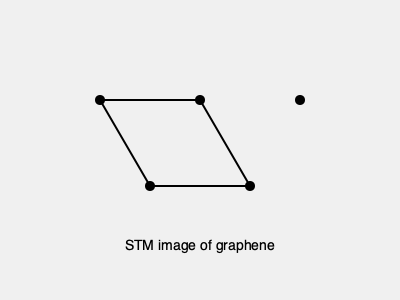Based on the STM image of graphene shown above, calculate the lattice constant of graphene. Assume the distance between the two adjacent bright spots in the horizontal direction is 0.246 nm. To calculate the lattice constant of graphene from the given STM image, we need to follow these steps:

1. Identify the unit cell: The hexagonal structure in the image represents the graphene lattice. The bright spots are the carbon atoms.

2. Recognize the given information: The distance between two adjacent bright spots in the horizontal direction is 0.246 nm. This corresponds to the distance between next-nearest neighbor carbon atoms in graphene.

3. Relate the given distance to the lattice constant:
   In graphene, the lattice constant $a$ is the distance between two nearest-neighbor carbon atoms multiplied by $\sqrt{3}$.

4. Calculate the lattice constant:
   Let $d$ be the distance between next-nearest neighbor atoms (0.246 nm).
   The relationship between $d$ and $a$ is: $d = a\sqrt{3}$

   Therefore, $a = \frac{d}{\sqrt{3}}$

5. Substitute the known value:
   $a = \frac{0.246 \text{ nm}}{\sqrt{3}}$

6. Compute the final result:
   $a \approx 0.142 \text{ nm}$

This value is consistent with the known lattice constant of graphene.
Answer: 0.142 nm 